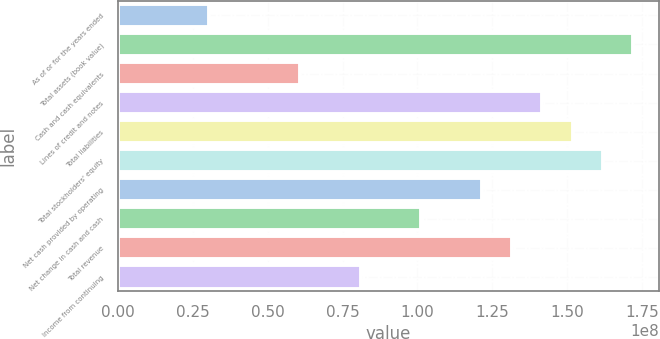<chart> <loc_0><loc_0><loc_500><loc_500><bar_chart><fcel>As of or for the years ended<fcel>Total assets (book value)<fcel>Cash and cash equivalents<fcel>Lines of credit and notes<fcel>Total liabilities<fcel>Total stockholders' equity<fcel>Net cash provided by operating<fcel>Net change in cash and cash<fcel>Total revenue<fcel>Income from continuing<nl><fcel>3.0363e+07<fcel>1.72057e+08<fcel>6.07259e+07<fcel>1.41694e+08<fcel>1.51815e+08<fcel>1.61936e+08<fcel>1.21452e+08<fcel>1.0121e+08<fcel>1.31573e+08<fcel>8.09679e+07<nl></chart> 